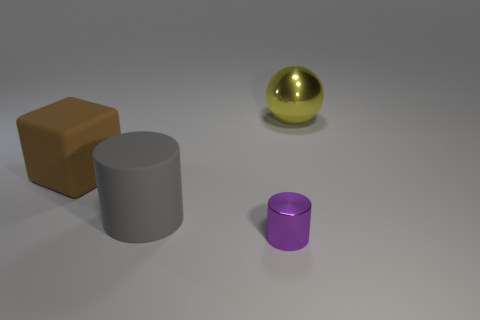Is there any other thing that is the same size as the purple cylinder?
Offer a very short reply. No. How many other objects are there of the same shape as the yellow metallic object?
Offer a terse response. 0. Is there a object made of the same material as the sphere?
Your answer should be compact. Yes. Is the shape of the metallic object behind the small object the same as  the large brown thing?
Make the answer very short. No. There is a shiny object that is behind the cylinder right of the big gray thing; how many gray rubber objects are in front of it?
Ensure brevity in your answer.  1. Is the number of gray objects that are in front of the purple metal cylinder less than the number of gray matte things that are on the right side of the big yellow ball?
Your response must be concise. No. There is another thing that is the same shape as the purple thing; what is its color?
Provide a succinct answer. Gray. What size is the rubber cylinder?
Your response must be concise. Large. What number of metal things are the same size as the brown rubber thing?
Provide a short and direct response. 1. Is the big matte cylinder the same color as the large cube?
Give a very brief answer. No. 